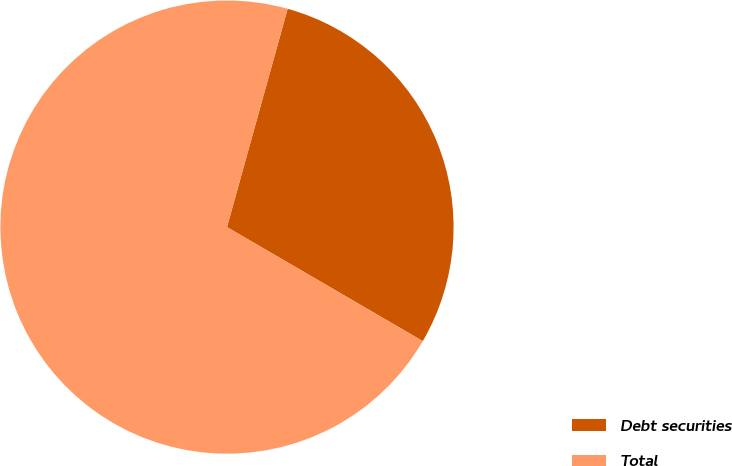<chart> <loc_0><loc_0><loc_500><loc_500><pie_chart><fcel>Debt securities<fcel>Total<nl><fcel>29.08%<fcel>70.92%<nl></chart> 